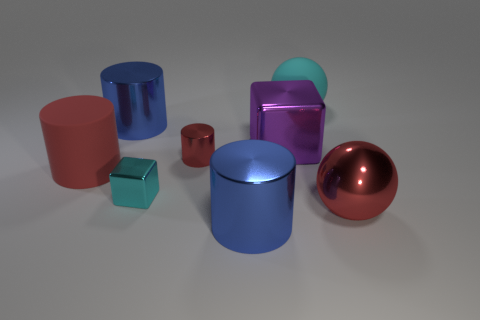Subtract all red matte cylinders. How many cylinders are left? 3 Subtract 2 cylinders. How many cylinders are left? 2 Subtract all cyan cubes. How many cubes are left? 1 Subtract all balls. How many objects are left? 6 Subtract all brown balls. How many blue cubes are left? 0 Subtract all big red shiny things. Subtract all big metallic spheres. How many objects are left? 6 Add 2 purple cubes. How many purple cubes are left? 3 Add 6 large metal things. How many large metal things exist? 10 Add 2 gray objects. How many objects exist? 10 Subtract 0 gray blocks. How many objects are left? 8 